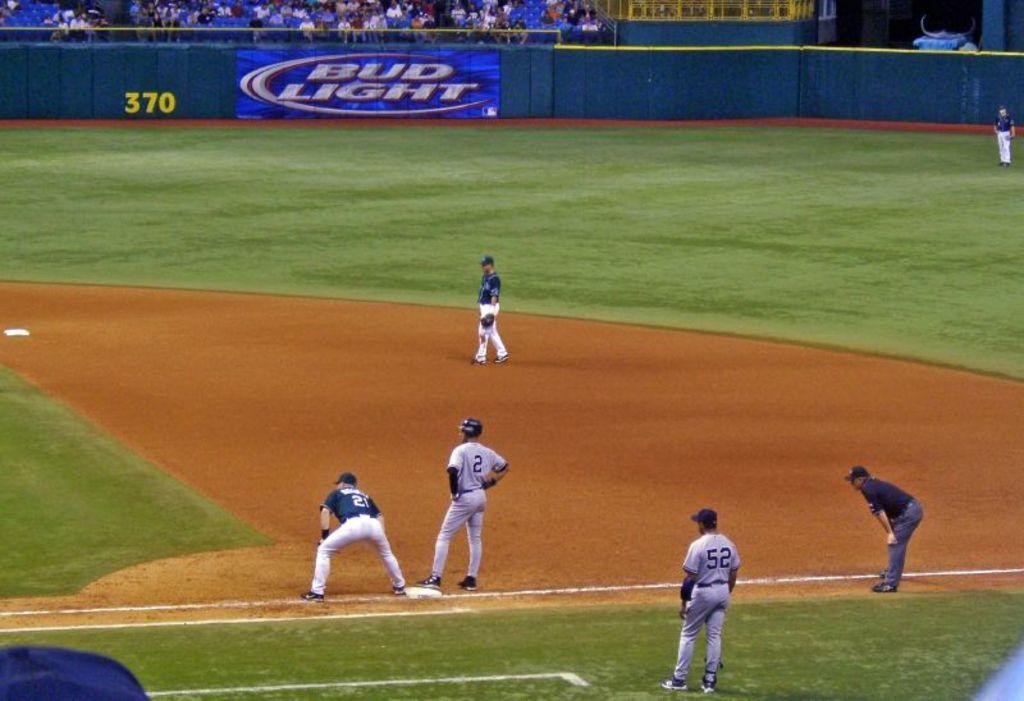What is one of their sponsors?
Ensure brevity in your answer.  Bud light. What is the number of the player in the gray shirt on base?
Make the answer very short. 2. 